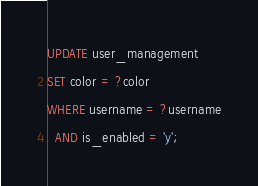Convert code to text. <code><loc_0><loc_0><loc_500><loc_500><_SQL_>UPDATE user_management
SET color = ?color
WHERE username = ?username
  AND is_enabled = 'y';
</code> 